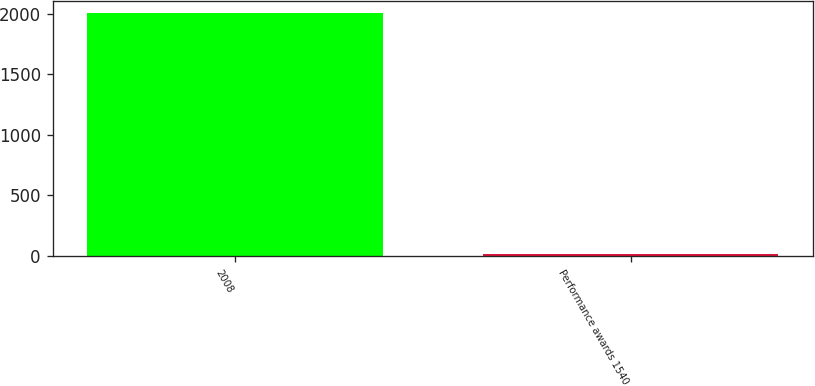Convert chart to OTSL. <chart><loc_0><loc_0><loc_500><loc_500><bar_chart><fcel>2008<fcel>Performance awards 1540<nl><fcel>2010<fcel>14.21<nl></chart> 